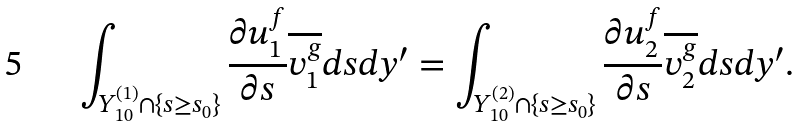<formula> <loc_0><loc_0><loc_500><loc_500>\int _ { Y _ { 1 0 } ^ { ( 1 ) } \cap \{ s \geq s _ { 0 } \} } \frac { \partial u _ { 1 } ^ { f } } { \partial s } \overline { v _ { 1 } ^ { g } } d s d y ^ { \prime } = \int _ { Y _ { 1 0 } ^ { ( 2 ) } \cap \{ s \geq s _ { 0 } \} } \frac { \partial u _ { 2 } ^ { f } } { \partial s } \overline { v _ { 2 } ^ { g } } d s d y ^ { \prime } .</formula> 